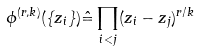<formula> <loc_0><loc_0><loc_500><loc_500>\phi ^ { ( r , k ) } ( \{ z _ { i } \} ) \hat { = } \prod _ { i < j } ( z _ { i } - z _ { j } ) ^ { r / k }</formula> 